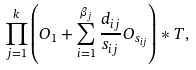Convert formula to latex. <formula><loc_0><loc_0><loc_500><loc_500>\prod _ { j = 1 } ^ { k } \left ( O _ { 1 } + \sum _ { i = 1 } ^ { \beta _ { j } } \frac { d _ { i j } } { s _ { i j } } O _ { s _ { i j } } \right ) * T ,</formula> 